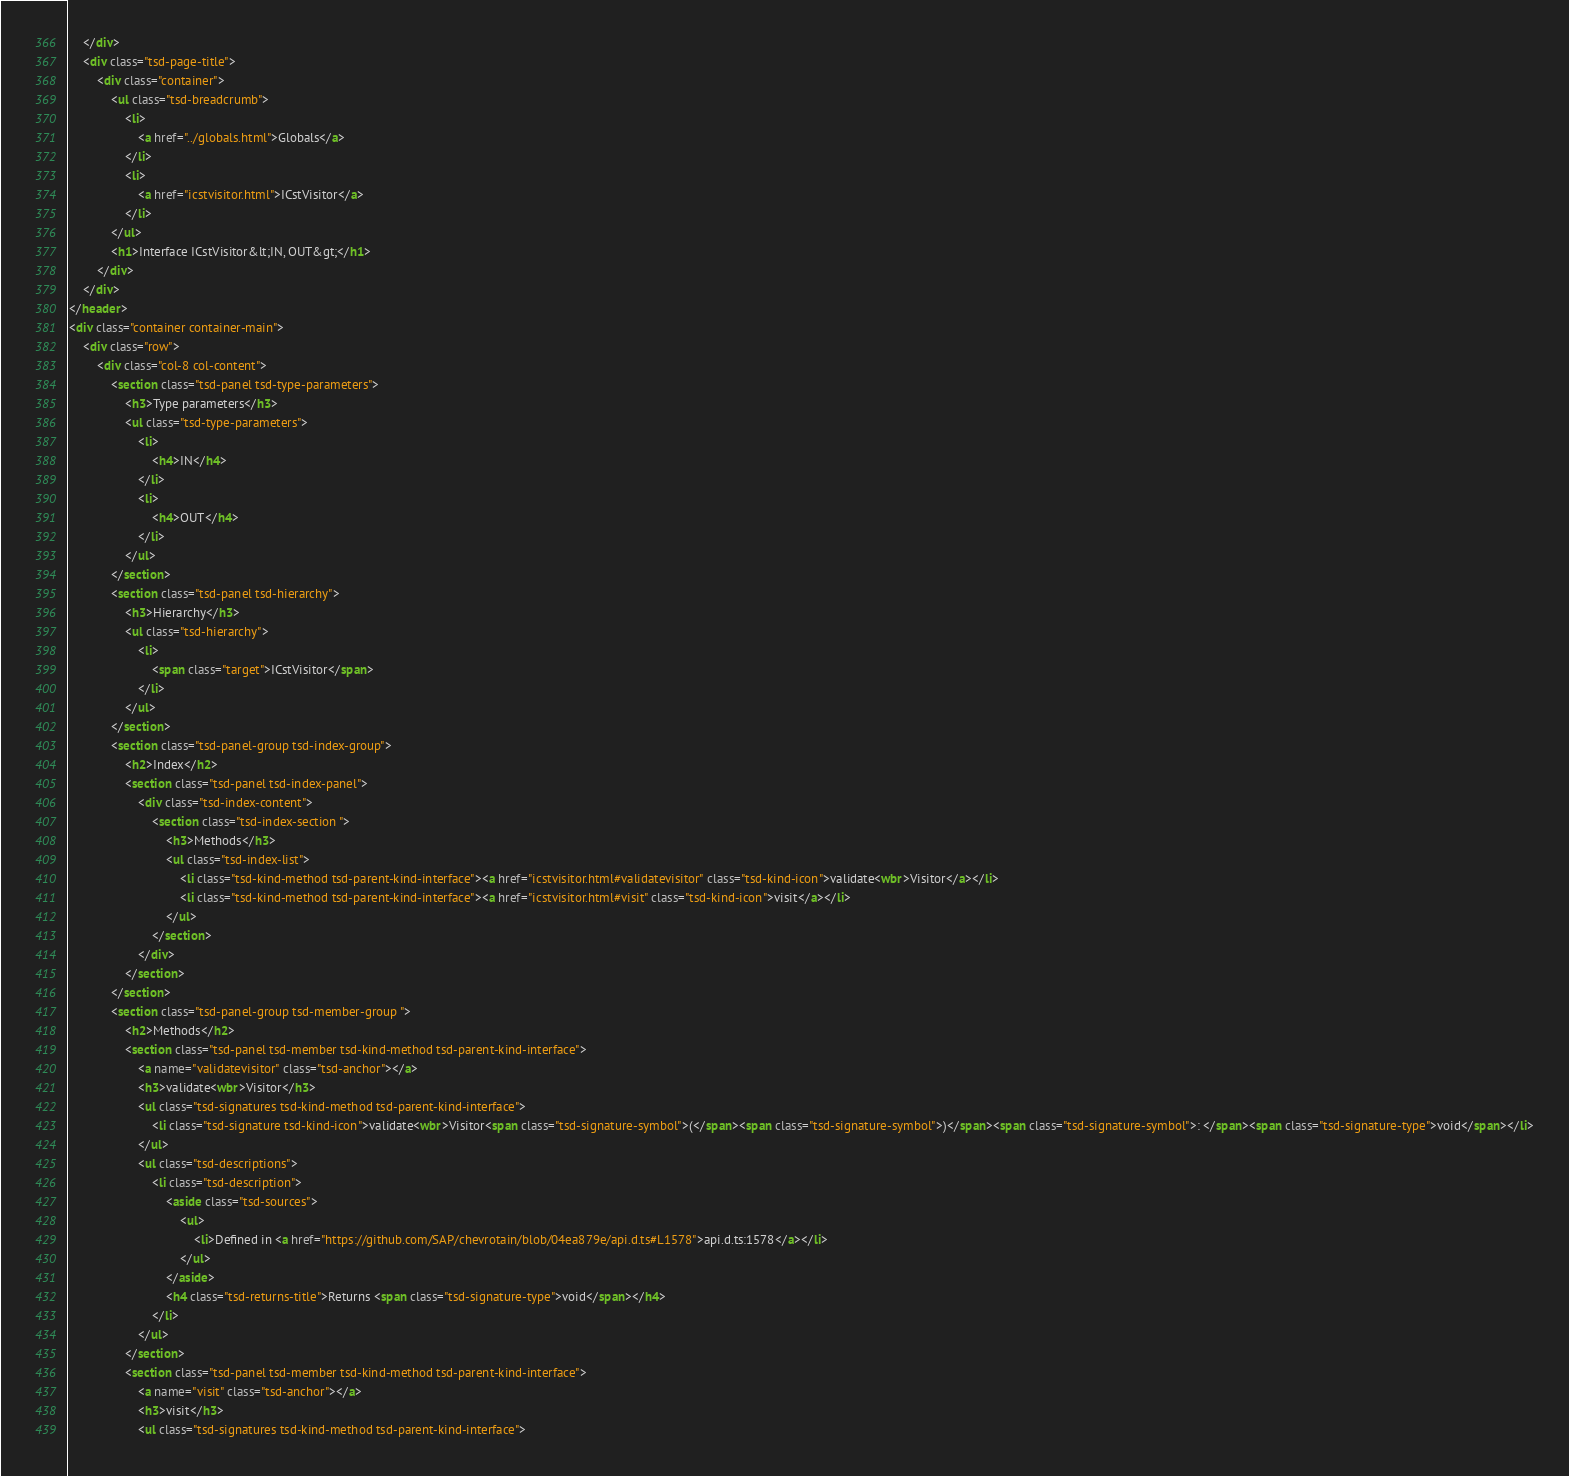Convert code to text. <code><loc_0><loc_0><loc_500><loc_500><_HTML_>	</div>
	<div class="tsd-page-title">
		<div class="container">
			<ul class="tsd-breadcrumb">
				<li>
					<a href="../globals.html">Globals</a>
				</li>
				<li>
					<a href="icstvisitor.html">ICstVisitor</a>
				</li>
			</ul>
			<h1>Interface ICstVisitor&lt;IN, OUT&gt;</h1>
		</div>
	</div>
</header>
<div class="container container-main">
	<div class="row">
		<div class="col-8 col-content">
			<section class="tsd-panel tsd-type-parameters">
				<h3>Type parameters</h3>
				<ul class="tsd-type-parameters">
					<li>
						<h4>IN</h4>
					</li>
					<li>
						<h4>OUT</h4>
					</li>
				</ul>
			</section>
			<section class="tsd-panel tsd-hierarchy">
				<h3>Hierarchy</h3>
				<ul class="tsd-hierarchy">
					<li>
						<span class="target">ICstVisitor</span>
					</li>
				</ul>
			</section>
			<section class="tsd-panel-group tsd-index-group">
				<h2>Index</h2>
				<section class="tsd-panel tsd-index-panel">
					<div class="tsd-index-content">
						<section class="tsd-index-section ">
							<h3>Methods</h3>
							<ul class="tsd-index-list">
								<li class="tsd-kind-method tsd-parent-kind-interface"><a href="icstvisitor.html#validatevisitor" class="tsd-kind-icon">validate<wbr>Visitor</a></li>
								<li class="tsd-kind-method tsd-parent-kind-interface"><a href="icstvisitor.html#visit" class="tsd-kind-icon">visit</a></li>
							</ul>
						</section>
					</div>
				</section>
			</section>
			<section class="tsd-panel-group tsd-member-group ">
				<h2>Methods</h2>
				<section class="tsd-panel tsd-member tsd-kind-method tsd-parent-kind-interface">
					<a name="validatevisitor" class="tsd-anchor"></a>
					<h3>validate<wbr>Visitor</h3>
					<ul class="tsd-signatures tsd-kind-method tsd-parent-kind-interface">
						<li class="tsd-signature tsd-kind-icon">validate<wbr>Visitor<span class="tsd-signature-symbol">(</span><span class="tsd-signature-symbol">)</span><span class="tsd-signature-symbol">: </span><span class="tsd-signature-type">void</span></li>
					</ul>
					<ul class="tsd-descriptions">
						<li class="tsd-description">
							<aside class="tsd-sources">
								<ul>
									<li>Defined in <a href="https://github.com/SAP/chevrotain/blob/04ea879e/api.d.ts#L1578">api.d.ts:1578</a></li>
								</ul>
							</aside>
							<h4 class="tsd-returns-title">Returns <span class="tsd-signature-type">void</span></h4>
						</li>
					</ul>
				</section>
				<section class="tsd-panel tsd-member tsd-kind-method tsd-parent-kind-interface">
					<a name="visit" class="tsd-anchor"></a>
					<h3>visit</h3>
					<ul class="tsd-signatures tsd-kind-method tsd-parent-kind-interface"></code> 